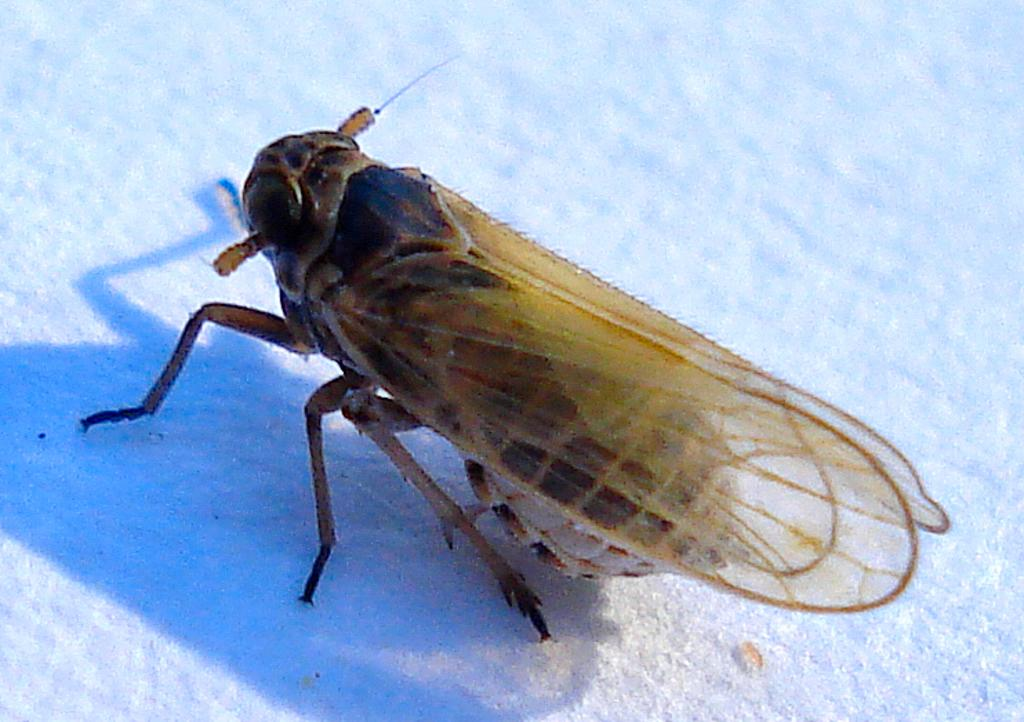Where was the image taken? The image was taken outdoors. What can be seen in the background of the image? There is snow in the background of the image. What is located in the middle of the image? There is a fly in the middle of the image. What type of honey is being collected by the bees in the image? There are no bees or honey present in the image; it features a fly in the snowy outdoors. 